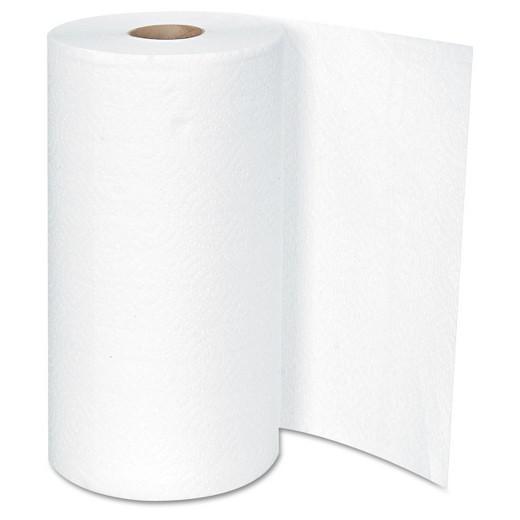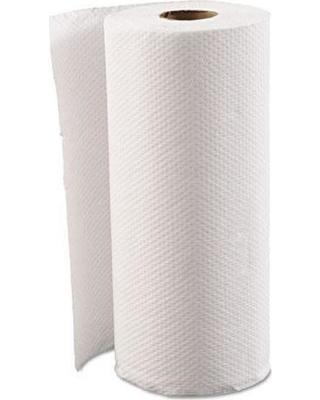The first image is the image on the left, the second image is the image on the right. Examine the images to the left and right. Is the description "Exactly two rolls of white paper towels are standing upright." accurate? Answer yes or no. Yes. The first image is the image on the left, the second image is the image on the right. Given the left and right images, does the statement "there are exactly two rolls of paper in the image on the left" hold true? Answer yes or no. No. 